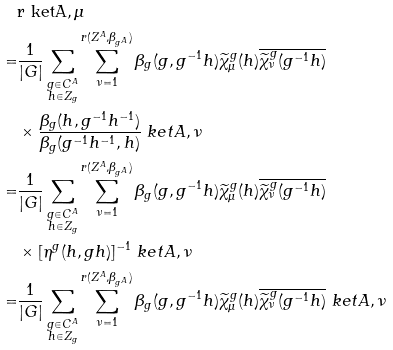<formula> <loc_0><loc_0><loc_500><loc_500>& \tt r \ k e t { A , \mu } \\ = & \frac { 1 } { | G | } \sum _ { \substack { g \in C ^ { A } \\ h \in Z _ { g } } } \sum _ { \nu = 1 } ^ { r ( Z ^ { A } , \beta _ { g ^ { A } } ) } { \beta _ { g } ( g , g ^ { - 1 } h ) } { \widetilde { \chi } ^ { g } _ { \mu } ( h ) } \overline { \widetilde { \chi } ^ { g } _ { \nu } ( g ^ { - 1 } h ) } \\ & \times \frac { \beta _ { g } ( h , g ^ { - 1 } h ^ { - 1 } ) } { \beta _ { g } ( g ^ { - 1 } h ^ { - 1 } , h ) } \ k e t { A , \nu } \\ = & \frac { 1 } { | G | } \sum _ { \substack { g \in C ^ { A } \\ h \in Z _ { g } } } \sum _ { \nu = 1 } ^ { r ( Z ^ { A } , \beta _ { g ^ { A } } ) } { \beta _ { g } ( g , g ^ { - 1 } h ) } { \widetilde { \chi } ^ { g } _ { \mu } ( h ) } \overline { \widetilde { \chi } ^ { g } _ { \nu } ( g ^ { - 1 } h ) } \\ & \times [ \eta ^ { g } ( h , g h ) ] ^ { - 1 } \ k e t { A , \nu } \\ = & \frac { 1 } { | G | } \sum _ { \substack { g \in C ^ { A } \\ h \in Z _ { g } } } \sum _ { \nu = 1 } ^ { r ( Z ^ { A } , \beta _ { g ^ { A } } ) } { \beta _ { g } ( g , g ^ { - 1 } h ) } { \widetilde { \chi } ^ { g } _ { \mu } ( h ) } \overline { \widetilde { \chi } ^ { g } _ { \nu } ( g ^ { - 1 } h ) } \ k e t { A , \nu }</formula> 